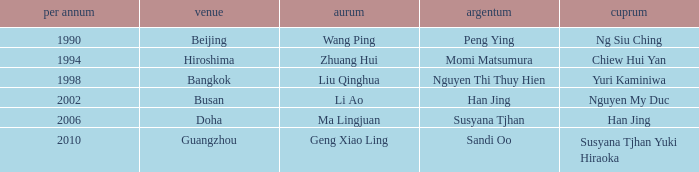What's the Bronze with the Year of 1998? Yuri Kaminiwa. 